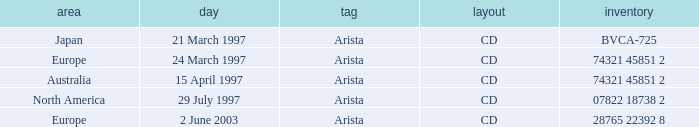What's the Date for the Region of Europe and has the Catalog of 28765 22392 8? 2 June 2003. Help me parse the entirety of this table. {'header': ['area', 'day', 'tag', 'layout', 'inventory'], 'rows': [['Japan', '21 March 1997', 'Arista', 'CD', 'BVCA-725'], ['Europe', '24 March 1997', 'Arista', 'CD', '74321 45851 2'], ['Australia', '15 April 1997', 'Arista', 'CD', '74321 45851 2'], ['North America', '29 July 1997', 'Arista', 'CD', '07822 18738 2'], ['Europe', '2 June 2003', 'Arista', 'CD', '28765 22392 8']]} 